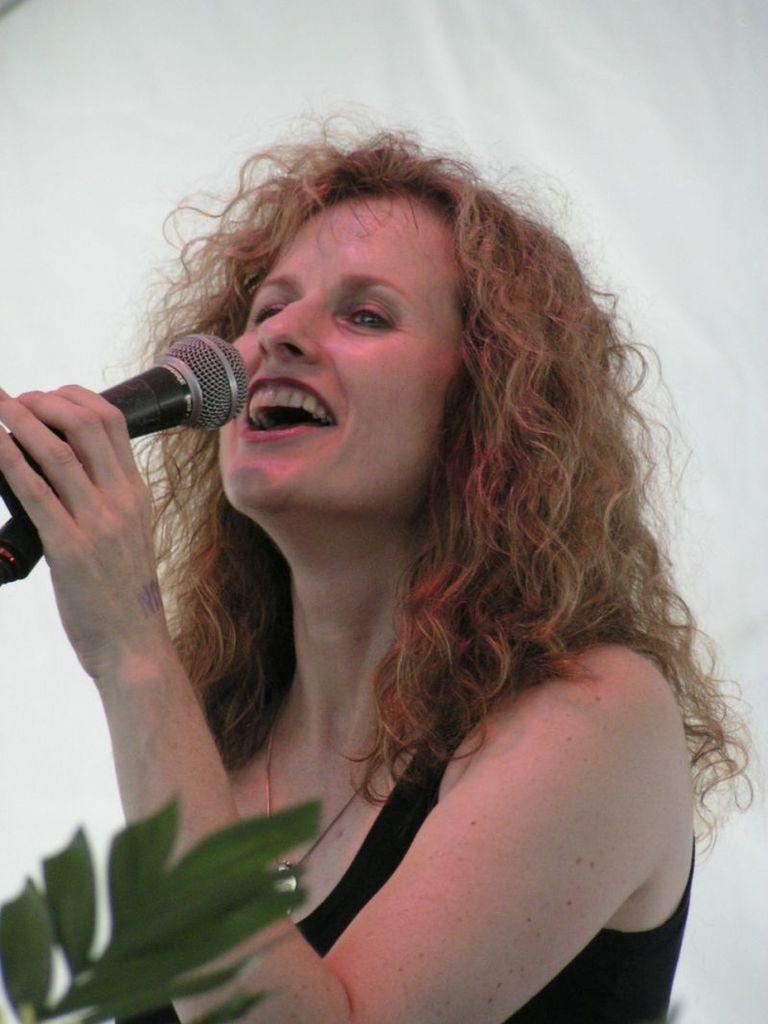Who is the main subject in the image? There is a woman in the image. What is the woman doing in the image? The woman is singing. What object is the woman holding in the image? The woman is holding a microphone. What type of natural elements can be seen in the image? There are leaves visible in the image, located at the bottom left. What is the woman's opinion on the size of the produce in the image? There is no produce present in the image, so it is not possible to determine the woman's opinion on its size. 